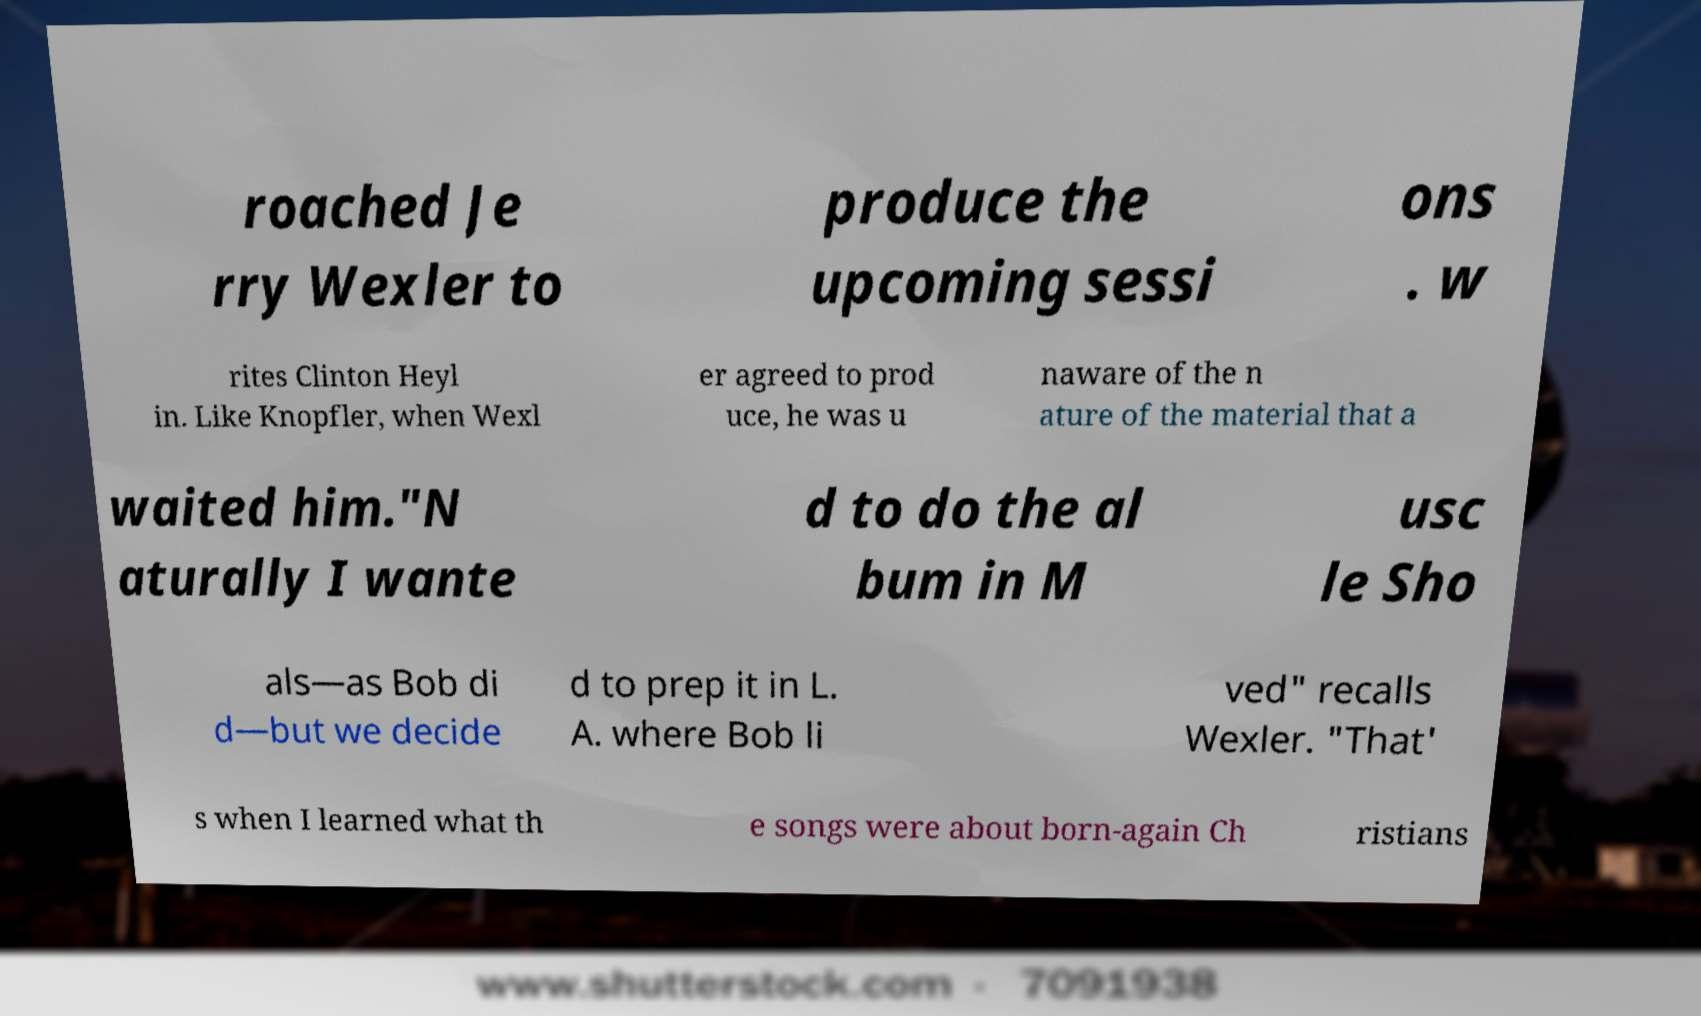Can you read and provide the text displayed in the image?This photo seems to have some interesting text. Can you extract and type it out for me? roached Je rry Wexler to produce the upcoming sessi ons . w rites Clinton Heyl in. Like Knopfler, when Wexl er agreed to prod uce, he was u naware of the n ature of the material that a waited him."N aturally I wante d to do the al bum in M usc le Sho als—as Bob di d—but we decide d to prep it in L. A. where Bob li ved" recalls Wexler. "That' s when I learned what th e songs were about born-again Ch ristians 